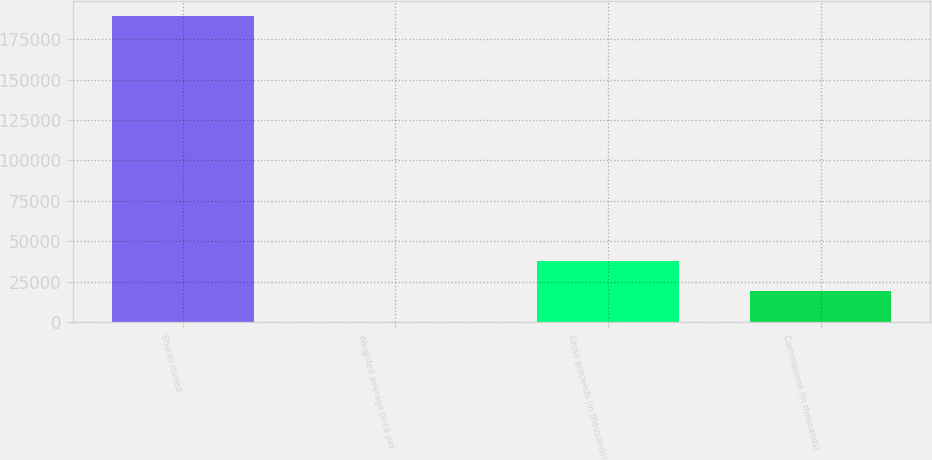Convert chart to OTSL. <chart><loc_0><loc_0><loc_500><loc_500><bar_chart><fcel>Shares issued<fcel>Weighted average price per<fcel>Gross proceeds (in thousands)<fcel>Commissions (in thousands)<nl><fcel>189266<fcel>67.86<fcel>37907.5<fcel>18987.7<nl></chart> 